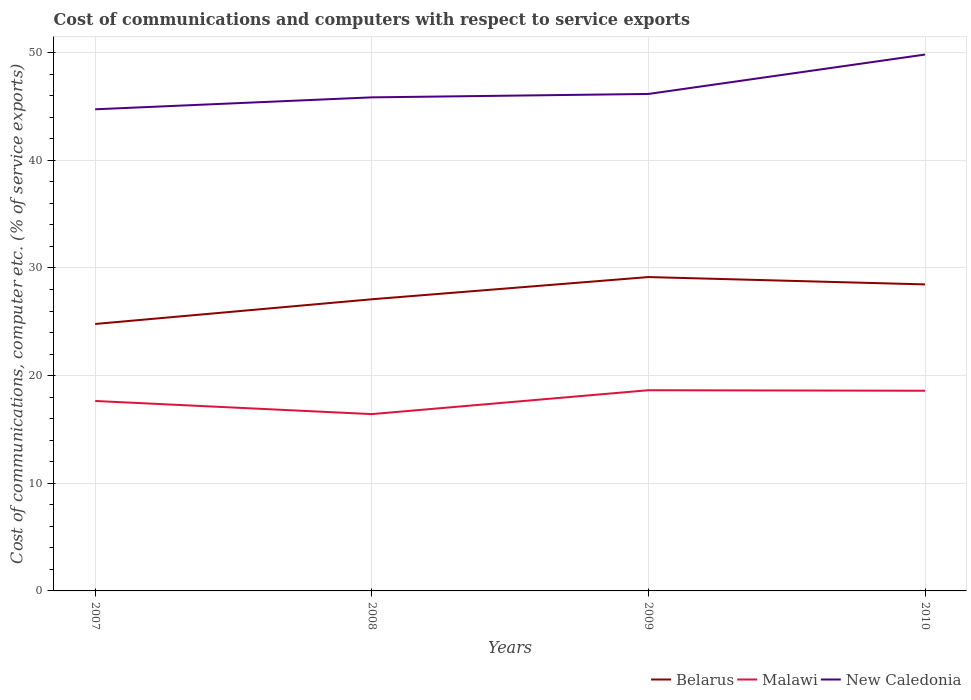Does the line corresponding to New Caledonia intersect with the line corresponding to Belarus?
Ensure brevity in your answer.  No. Across all years, what is the maximum cost of communications and computers in New Caledonia?
Keep it short and to the point. 44.74. What is the total cost of communications and computers in Malawi in the graph?
Provide a succinct answer. -0.95. What is the difference between the highest and the second highest cost of communications and computers in Belarus?
Make the answer very short. 4.36. Is the cost of communications and computers in Belarus strictly greater than the cost of communications and computers in New Caledonia over the years?
Give a very brief answer. Yes. How many years are there in the graph?
Make the answer very short. 4. What is the difference between two consecutive major ticks on the Y-axis?
Give a very brief answer. 10. Are the values on the major ticks of Y-axis written in scientific E-notation?
Provide a succinct answer. No. Does the graph contain any zero values?
Your answer should be very brief. No. How are the legend labels stacked?
Ensure brevity in your answer.  Horizontal. What is the title of the graph?
Your response must be concise. Cost of communications and computers with respect to service exports. Does "Cyprus" appear as one of the legend labels in the graph?
Offer a very short reply. No. What is the label or title of the X-axis?
Offer a terse response. Years. What is the label or title of the Y-axis?
Keep it short and to the point. Cost of communications, computer etc. (% of service exports). What is the Cost of communications, computer etc. (% of service exports) of Belarus in 2007?
Keep it short and to the point. 24.8. What is the Cost of communications, computer etc. (% of service exports) in Malawi in 2007?
Offer a terse response. 17.64. What is the Cost of communications, computer etc. (% of service exports) of New Caledonia in 2007?
Your answer should be very brief. 44.74. What is the Cost of communications, computer etc. (% of service exports) of Belarus in 2008?
Keep it short and to the point. 27.09. What is the Cost of communications, computer etc. (% of service exports) of Malawi in 2008?
Keep it short and to the point. 16.43. What is the Cost of communications, computer etc. (% of service exports) of New Caledonia in 2008?
Your response must be concise. 45.85. What is the Cost of communications, computer etc. (% of service exports) in Belarus in 2009?
Make the answer very short. 29.16. What is the Cost of communications, computer etc. (% of service exports) in Malawi in 2009?
Offer a very short reply. 18.64. What is the Cost of communications, computer etc. (% of service exports) in New Caledonia in 2009?
Your response must be concise. 46.17. What is the Cost of communications, computer etc. (% of service exports) in Belarus in 2010?
Your response must be concise. 28.47. What is the Cost of communications, computer etc. (% of service exports) in Malawi in 2010?
Your answer should be very brief. 18.59. What is the Cost of communications, computer etc. (% of service exports) in New Caledonia in 2010?
Offer a very short reply. 49.83. Across all years, what is the maximum Cost of communications, computer etc. (% of service exports) in Belarus?
Give a very brief answer. 29.16. Across all years, what is the maximum Cost of communications, computer etc. (% of service exports) in Malawi?
Make the answer very short. 18.64. Across all years, what is the maximum Cost of communications, computer etc. (% of service exports) of New Caledonia?
Your response must be concise. 49.83. Across all years, what is the minimum Cost of communications, computer etc. (% of service exports) in Belarus?
Give a very brief answer. 24.8. Across all years, what is the minimum Cost of communications, computer etc. (% of service exports) in Malawi?
Offer a terse response. 16.43. Across all years, what is the minimum Cost of communications, computer etc. (% of service exports) in New Caledonia?
Offer a very short reply. 44.74. What is the total Cost of communications, computer etc. (% of service exports) of Belarus in the graph?
Your response must be concise. 109.52. What is the total Cost of communications, computer etc. (% of service exports) in Malawi in the graph?
Give a very brief answer. 71.31. What is the total Cost of communications, computer etc. (% of service exports) in New Caledonia in the graph?
Your response must be concise. 186.58. What is the difference between the Cost of communications, computer etc. (% of service exports) in Belarus in 2007 and that in 2008?
Your answer should be very brief. -2.29. What is the difference between the Cost of communications, computer etc. (% of service exports) in Malawi in 2007 and that in 2008?
Offer a very short reply. 1.22. What is the difference between the Cost of communications, computer etc. (% of service exports) in New Caledonia in 2007 and that in 2008?
Your answer should be compact. -1.11. What is the difference between the Cost of communications, computer etc. (% of service exports) of Belarus in 2007 and that in 2009?
Make the answer very short. -4.36. What is the difference between the Cost of communications, computer etc. (% of service exports) in Malawi in 2007 and that in 2009?
Your answer should be compact. -1. What is the difference between the Cost of communications, computer etc. (% of service exports) in New Caledonia in 2007 and that in 2009?
Provide a short and direct response. -1.42. What is the difference between the Cost of communications, computer etc. (% of service exports) of Belarus in 2007 and that in 2010?
Offer a very short reply. -3.68. What is the difference between the Cost of communications, computer etc. (% of service exports) of Malawi in 2007 and that in 2010?
Offer a terse response. -0.95. What is the difference between the Cost of communications, computer etc. (% of service exports) in New Caledonia in 2007 and that in 2010?
Give a very brief answer. -5.08. What is the difference between the Cost of communications, computer etc. (% of service exports) of Belarus in 2008 and that in 2009?
Give a very brief answer. -2.06. What is the difference between the Cost of communications, computer etc. (% of service exports) of Malawi in 2008 and that in 2009?
Keep it short and to the point. -2.22. What is the difference between the Cost of communications, computer etc. (% of service exports) of New Caledonia in 2008 and that in 2009?
Your answer should be very brief. -0.32. What is the difference between the Cost of communications, computer etc. (% of service exports) in Belarus in 2008 and that in 2010?
Provide a succinct answer. -1.38. What is the difference between the Cost of communications, computer etc. (% of service exports) in Malawi in 2008 and that in 2010?
Offer a terse response. -2.17. What is the difference between the Cost of communications, computer etc. (% of service exports) of New Caledonia in 2008 and that in 2010?
Your response must be concise. -3.98. What is the difference between the Cost of communications, computer etc. (% of service exports) of Belarus in 2009 and that in 2010?
Ensure brevity in your answer.  0.68. What is the difference between the Cost of communications, computer etc. (% of service exports) of Malawi in 2009 and that in 2010?
Give a very brief answer. 0.05. What is the difference between the Cost of communications, computer etc. (% of service exports) of New Caledonia in 2009 and that in 2010?
Offer a terse response. -3.66. What is the difference between the Cost of communications, computer etc. (% of service exports) in Belarus in 2007 and the Cost of communications, computer etc. (% of service exports) in Malawi in 2008?
Keep it short and to the point. 8.37. What is the difference between the Cost of communications, computer etc. (% of service exports) of Belarus in 2007 and the Cost of communications, computer etc. (% of service exports) of New Caledonia in 2008?
Make the answer very short. -21.05. What is the difference between the Cost of communications, computer etc. (% of service exports) in Malawi in 2007 and the Cost of communications, computer etc. (% of service exports) in New Caledonia in 2008?
Your answer should be very brief. -28.2. What is the difference between the Cost of communications, computer etc. (% of service exports) in Belarus in 2007 and the Cost of communications, computer etc. (% of service exports) in Malawi in 2009?
Make the answer very short. 6.15. What is the difference between the Cost of communications, computer etc. (% of service exports) in Belarus in 2007 and the Cost of communications, computer etc. (% of service exports) in New Caledonia in 2009?
Make the answer very short. -21.37. What is the difference between the Cost of communications, computer etc. (% of service exports) in Malawi in 2007 and the Cost of communications, computer etc. (% of service exports) in New Caledonia in 2009?
Ensure brevity in your answer.  -28.52. What is the difference between the Cost of communications, computer etc. (% of service exports) in Belarus in 2007 and the Cost of communications, computer etc. (% of service exports) in Malawi in 2010?
Provide a succinct answer. 6.2. What is the difference between the Cost of communications, computer etc. (% of service exports) of Belarus in 2007 and the Cost of communications, computer etc. (% of service exports) of New Caledonia in 2010?
Ensure brevity in your answer.  -25.03. What is the difference between the Cost of communications, computer etc. (% of service exports) of Malawi in 2007 and the Cost of communications, computer etc. (% of service exports) of New Caledonia in 2010?
Offer a very short reply. -32.18. What is the difference between the Cost of communications, computer etc. (% of service exports) in Belarus in 2008 and the Cost of communications, computer etc. (% of service exports) in Malawi in 2009?
Ensure brevity in your answer.  8.45. What is the difference between the Cost of communications, computer etc. (% of service exports) in Belarus in 2008 and the Cost of communications, computer etc. (% of service exports) in New Caledonia in 2009?
Ensure brevity in your answer.  -19.07. What is the difference between the Cost of communications, computer etc. (% of service exports) of Malawi in 2008 and the Cost of communications, computer etc. (% of service exports) of New Caledonia in 2009?
Your answer should be compact. -29.74. What is the difference between the Cost of communications, computer etc. (% of service exports) in Belarus in 2008 and the Cost of communications, computer etc. (% of service exports) in Malawi in 2010?
Ensure brevity in your answer.  8.5. What is the difference between the Cost of communications, computer etc. (% of service exports) in Belarus in 2008 and the Cost of communications, computer etc. (% of service exports) in New Caledonia in 2010?
Make the answer very short. -22.73. What is the difference between the Cost of communications, computer etc. (% of service exports) in Malawi in 2008 and the Cost of communications, computer etc. (% of service exports) in New Caledonia in 2010?
Provide a succinct answer. -33.4. What is the difference between the Cost of communications, computer etc. (% of service exports) of Belarus in 2009 and the Cost of communications, computer etc. (% of service exports) of Malawi in 2010?
Offer a terse response. 10.56. What is the difference between the Cost of communications, computer etc. (% of service exports) in Belarus in 2009 and the Cost of communications, computer etc. (% of service exports) in New Caledonia in 2010?
Your answer should be very brief. -20.67. What is the difference between the Cost of communications, computer etc. (% of service exports) in Malawi in 2009 and the Cost of communications, computer etc. (% of service exports) in New Caledonia in 2010?
Your answer should be compact. -31.18. What is the average Cost of communications, computer etc. (% of service exports) in Belarus per year?
Your response must be concise. 27.38. What is the average Cost of communications, computer etc. (% of service exports) in Malawi per year?
Offer a very short reply. 17.83. What is the average Cost of communications, computer etc. (% of service exports) of New Caledonia per year?
Provide a succinct answer. 46.65. In the year 2007, what is the difference between the Cost of communications, computer etc. (% of service exports) in Belarus and Cost of communications, computer etc. (% of service exports) in Malawi?
Provide a succinct answer. 7.15. In the year 2007, what is the difference between the Cost of communications, computer etc. (% of service exports) of Belarus and Cost of communications, computer etc. (% of service exports) of New Caledonia?
Keep it short and to the point. -19.94. In the year 2007, what is the difference between the Cost of communications, computer etc. (% of service exports) in Malawi and Cost of communications, computer etc. (% of service exports) in New Caledonia?
Offer a terse response. -27.1. In the year 2008, what is the difference between the Cost of communications, computer etc. (% of service exports) of Belarus and Cost of communications, computer etc. (% of service exports) of Malawi?
Give a very brief answer. 10.67. In the year 2008, what is the difference between the Cost of communications, computer etc. (% of service exports) of Belarus and Cost of communications, computer etc. (% of service exports) of New Caledonia?
Offer a very short reply. -18.76. In the year 2008, what is the difference between the Cost of communications, computer etc. (% of service exports) in Malawi and Cost of communications, computer etc. (% of service exports) in New Caledonia?
Provide a short and direct response. -29.42. In the year 2009, what is the difference between the Cost of communications, computer etc. (% of service exports) of Belarus and Cost of communications, computer etc. (% of service exports) of Malawi?
Your answer should be very brief. 10.51. In the year 2009, what is the difference between the Cost of communications, computer etc. (% of service exports) of Belarus and Cost of communications, computer etc. (% of service exports) of New Caledonia?
Ensure brevity in your answer.  -17.01. In the year 2009, what is the difference between the Cost of communications, computer etc. (% of service exports) of Malawi and Cost of communications, computer etc. (% of service exports) of New Caledonia?
Your answer should be very brief. -27.52. In the year 2010, what is the difference between the Cost of communications, computer etc. (% of service exports) of Belarus and Cost of communications, computer etc. (% of service exports) of Malawi?
Your answer should be compact. 9.88. In the year 2010, what is the difference between the Cost of communications, computer etc. (% of service exports) of Belarus and Cost of communications, computer etc. (% of service exports) of New Caledonia?
Provide a short and direct response. -21.35. In the year 2010, what is the difference between the Cost of communications, computer etc. (% of service exports) of Malawi and Cost of communications, computer etc. (% of service exports) of New Caledonia?
Offer a very short reply. -31.23. What is the ratio of the Cost of communications, computer etc. (% of service exports) of Belarus in 2007 to that in 2008?
Provide a succinct answer. 0.92. What is the ratio of the Cost of communications, computer etc. (% of service exports) in Malawi in 2007 to that in 2008?
Give a very brief answer. 1.07. What is the ratio of the Cost of communications, computer etc. (% of service exports) in New Caledonia in 2007 to that in 2008?
Give a very brief answer. 0.98. What is the ratio of the Cost of communications, computer etc. (% of service exports) of Belarus in 2007 to that in 2009?
Offer a terse response. 0.85. What is the ratio of the Cost of communications, computer etc. (% of service exports) of Malawi in 2007 to that in 2009?
Your answer should be compact. 0.95. What is the ratio of the Cost of communications, computer etc. (% of service exports) of New Caledonia in 2007 to that in 2009?
Your response must be concise. 0.97. What is the ratio of the Cost of communications, computer etc. (% of service exports) of Belarus in 2007 to that in 2010?
Give a very brief answer. 0.87. What is the ratio of the Cost of communications, computer etc. (% of service exports) of Malawi in 2007 to that in 2010?
Your answer should be very brief. 0.95. What is the ratio of the Cost of communications, computer etc. (% of service exports) of New Caledonia in 2007 to that in 2010?
Give a very brief answer. 0.9. What is the ratio of the Cost of communications, computer etc. (% of service exports) in Belarus in 2008 to that in 2009?
Offer a very short reply. 0.93. What is the ratio of the Cost of communications, computer etc. (% of service exports) of Malawi in 2008 to that in 2009?
Provide a succinct answer. 0.88. What is the ratio of the Cost of communications, computer etc. (% of service exports) of Belarus in 2008 to that in 2010?
Your answer should be compact. 0.95. What is the ratio of the Cost of communications, computer etc. (% of service exports) in Malawi in 2008 to that in 2010?
Make the answer very short. 0.88. What is the ratio of the Cost of communications, computer etc. (% of service exports) in New Caledonia in 2008 to that in 2010?
Your answer should be compact. 0.92. What is the ratio of the Cost of communications, computer etc. (% of service exports) in Belarus in 2009 to that in 2010?
Provide a succinct answer. 1.02. What is the ratio of the Cost of communications, computer etc. (% of service exports) in New Caledonia in 2009 to that in 2010?
Offer a very short reply. 0.93. What is the difference between the highest and the second highest Cost of communications, computer etc. (% of service exports) of Belarus?
Make the answer very short. 0.68. What is the difference between the highest and the second highest Cost of communications, computer etc. (% of service exports) in Malawi?
Provide a short and direct response. 0.05. What is the difference between the highest and the second highest Cost of communications, computer etc. (% of service exports) in New Caledonia?
Offer a very short reply. 3.66. What is the difference between the highest and the lowest Cost of communications, computer etc. (% of service exports) of Belarus?
Your response must be concise. 4.36. What is the difference between the highest and the lowest Cost of communications, computer etc. (% of service exports) in Malawi?
Your response must be concise. 2.22. What is the difference between the highest and the lowest Cost of communications, computer etc. (% of service exports) of New Caledonia?
Make the answer very short. 5.08. 